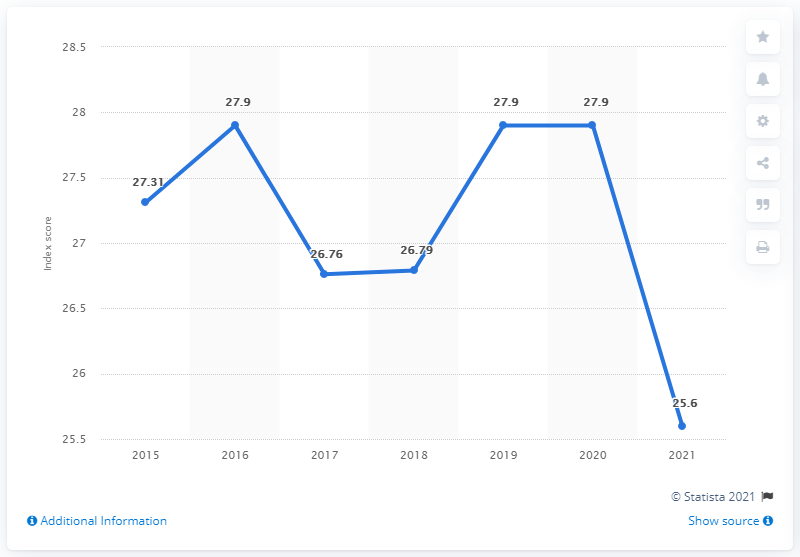What might have caused the sharp decline in the press freedom index in the most recent year shown on the graph? While the graph doesn't provide specific causes, various factors could contribute to the sharp decline in the press freedom index in the most recent year presented. These factors could include new legislation impacting media freedom, governmental crackdowns on journalists and media outlets, the emergence of substantial political unrest, or increased censorship. To fully understand this decline, one would need to consult more detailed reports or news articles from that year for context. 